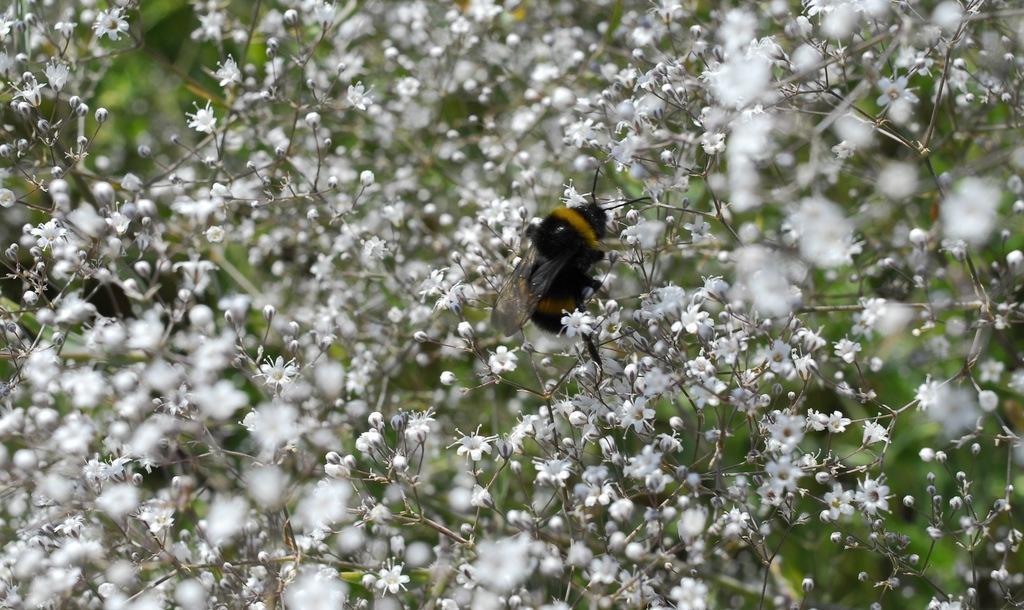Can you describe this image briefly? In the center of the image there is a insect. There are many flowers. 